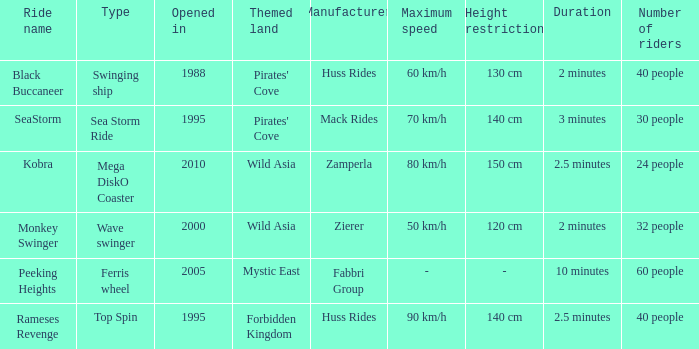What type ride is Wild Asia that opened in 2000? Wave swinger. 